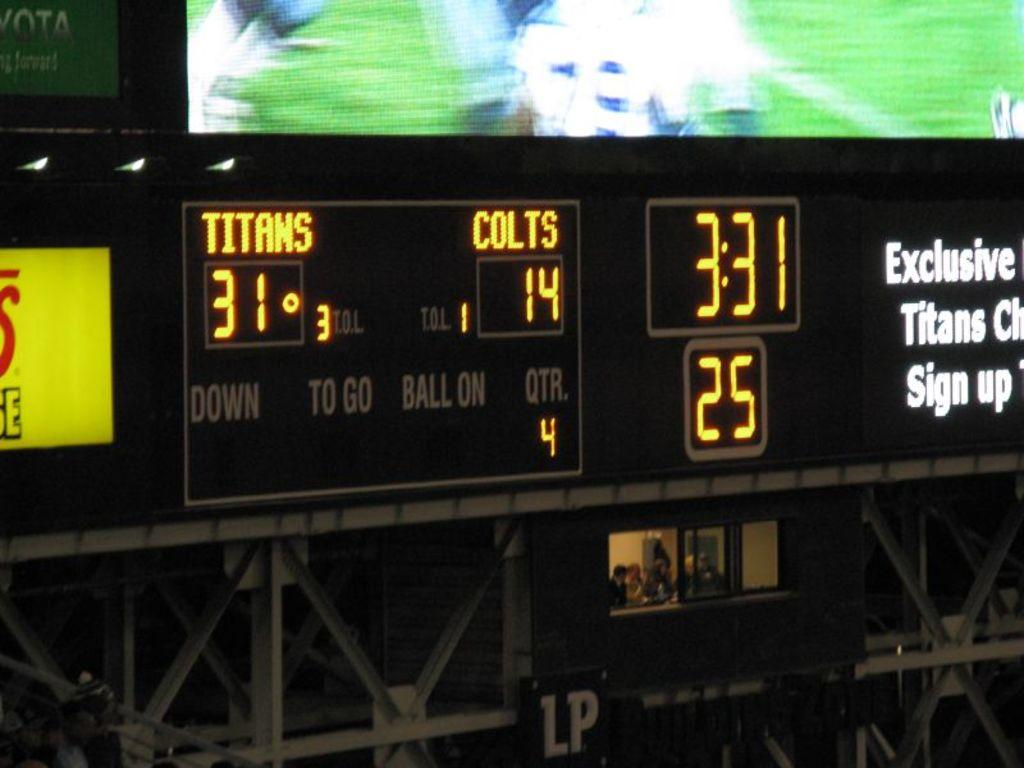<image>
Present a compact description of the photo's key features. the time of 3:31 that is on a clock 